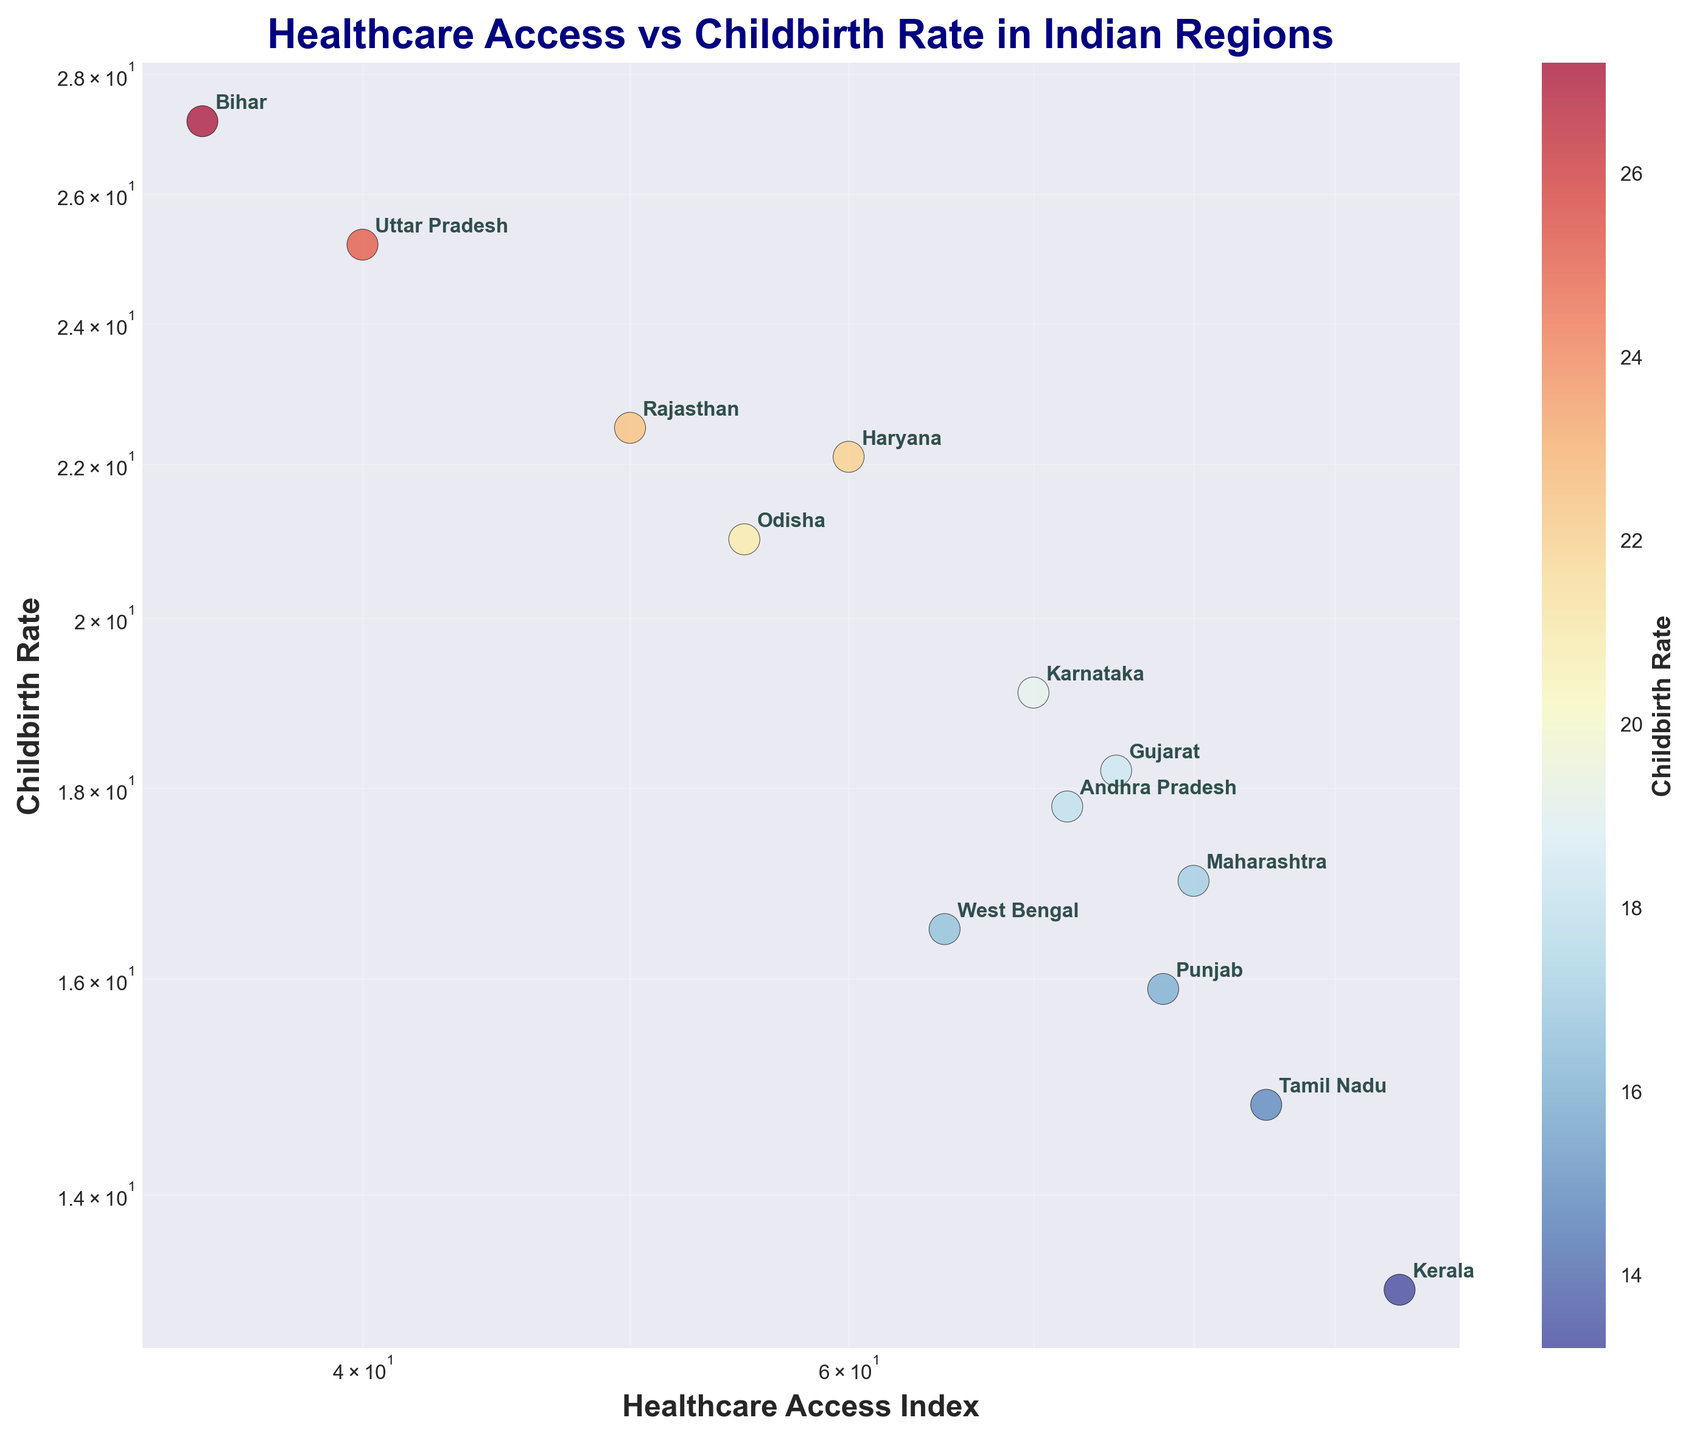What is the title of the figure? The title of the figure is located at the top, and it provides a brief description of what the figure is about.
Answer: Healthcare Access vs Childbirth Rate in Indian Regions How many regions are represented in the scatter plot? To determine the number of regions, we count the number of data points or labels shown near the points. Each point represents a region.
Answer: 13 Which region has the highest Healthcare Access Index? By looking at the x-axis with values on the log scale, we identify the region positioned farthest to the right.
Answer: Kerala What region has the highest Childbirth Rate? By examining the y-axis on the log scale, we find the region positioned highest on the graph.
Answer: Bihar How does Karnataka's Childbirth Rate compare to Maharashtra's? Karnataka is represented by one point, and Maharashtra by another. By comparing their positions along the y-axis on a log scale, we can determine which has a higher childbirth rate.
Answer: Higher Which regions have a Childbirth Rate below 15? By assessing the points positioned below the y-axis value of 15 on the log scale, we determine the regions.
Answer: Tamil Nadu, Kerala, Punjab What is the approximate range of the Healthcare Access Index for regions with a Childbirth Rate between 14 and 18? Look at the y-axis values between 14 and 18 on a log scale and find corresponding x-axis values to determine the range.
Answer: Approximately 65 to 85 Among the regions with Healthcare Access Index above 75, which has the highest Childbirth Rate? First, identify regions with a Healthcare Access Index above 75 based on the x-axis (log scale). Then, among these regions, find the one with the highest point on the y-axis.
Answer: Gujarat Which two regions are closest in Childbirth Rate but differ significantly in Healthcare Access Index? Look for points that are close together along the y-axis but far apart along the x-axis.
Answer: Maharashtra and West Bengal Is there a general trend between Healthcare Access Index and Childbirth Rate? Analyze the overall positioning of the data points to determine if there is an increasing or decreasing pattern.
Answer: Decreasing 